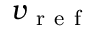Convert formula to latex. <formula><loc_0><loc_0><loc_500><loc_500>v _ { r e f }</formula> 